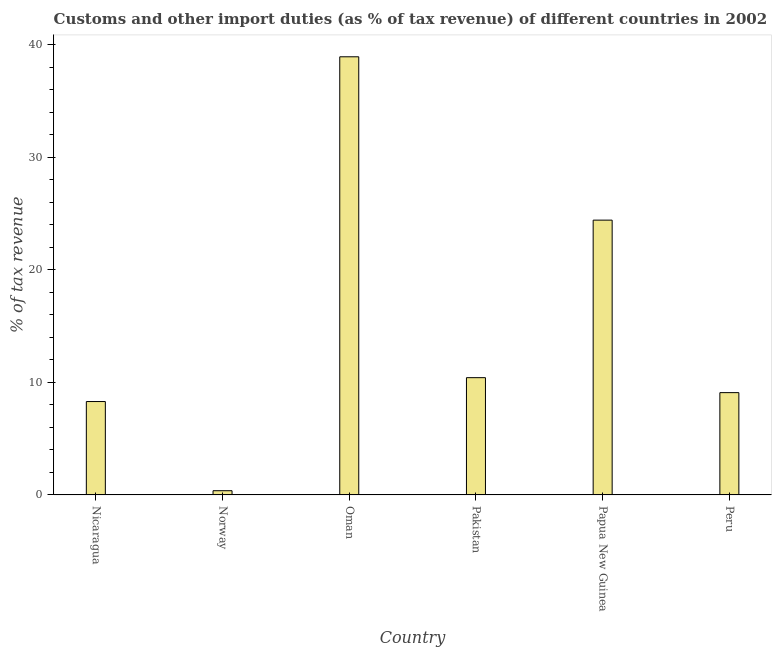Does the graph contain grids?
Provide a succinct answer. No. What is the title of the graph?
Ensure brevity in your answer.  Customs and other import duties (as % of tax revenue) of different countries in 2002. What is the label or title of the X-axis?
Your answer should be compact. Country. What is the label or title of the Y-axis?
Offer a very short reply. % of tax revenue. What is the customs and other import duties in Norway?
Your response must be concise. 0.38. Across all countries, what is the maximum customs and other import duties?
Offer a very short reply. 38.91. Across all countries, what is the minimum customs and other import duties?
Provide a short and direct response. 0.38. In which country was the customs and other import duties maximum?
Your answer should be very brief. Oman. What is the sum of the customs and other import duties?
Offer a very short reply. 91.49. What is the difference between the customs and other import duties in Nicaragua and Peru?
Your answer should be compact. -0.79. What is the average customs and other import duties per country?
Offer a very short reply. 15.25. What is the median customs and other import duties?
Your answer should be compact. 9.75. What is the ratio of the customs and other import duties in Nicaragua to that in Pakistan?
Make the answer very short. 0.8. Is the customs and other import duties in Nicaragua less than that in Papua New Guinea?
Your answer should be very brief. Yes. What is the difference between the highest and the second highest customs and other import duties?
Offer a terse response. 14.51. Is the sum of the customs and other import duties in Nicaragua and Oman greater than the maximum customs and other import duties across all countries?
Your response must be concise. Yes. What is the difference between the highest and the lowest customs and other import duties?
Give a very brief answer. 38.54. In how many countries, is the customs and other import duties greater than the average customs and other import duties taken over all countries?
Make the answer very short. 2. How many bars are there?
Ensure brevity in your answer.  6. How many countries are there in the graph?
Provide a succinct answer. 6. What is the % of tax revenue of Nicaragua?
Ensure brevity in your answer.  8.29. What is the % of tax revenue of Norway?
Offer a very short reply. 0.38. What is the % of tax revenue of Oman?
Provide a short and direct response. 38.91. What is the % of tax revenue in Pakistan?
Provide a succinct answer. 10.41. What is the % of tax revenue in Papua New Guinea?
Provide a succinct answer. 24.41. What is the % of tax revenue in Peru?
Offer a very short reply. 9.09. What is the difference between the % of tax revenue in Nicaragua and Norway?
Make the answer very short. 7.92. What is the difference between the % of tax revenue in Nicaragua and Oman?
Your answer should be very brief. -30.62. What is the difference between the % of tax revenue in Nicaragua and Pakistan?
Provide a succinct answer. -2.12. What is the difference between the % of tax revenue in Nicaragua and Papua New Guinea?
Keep it short and to the point. -16.11. What is the difference between the % of tax revenue in Nicaragua and Peru?
Give a very brief answer. -0.79. What is the difference between the % of tax revenue in Norway and Oman?
Your response must be concise. -38.54. What is the difference between the % of tax revenue in Norway and Pakistan?
Make the answer very short. -10.04. What is the difference between the % of tax revenue in Norway and Papua New Guinea?
Ensure brevity in your answer.  -24.03. What is the difference between the % of tax revenue in Norway and Peru?
Make the answer very short. -8.71. What is the difference between the % of tax revenue in Oman and Pakistan?
Provide a succinct answer. 28.5. What is the difference between the % of tax revenue in Oman and Papua New Guinea?
Provide a succinct answer. 14.51. What is the difference between the % of tax revenue in Oman and Peru?
Keep it short and to the point. 29.83. What is the difference between the % of tax revenue in Pakistan and Papua New Guinea?
Ensure brevity in your answer.  -13.99. What is the difference between the % of tax revenue in Pakistan and Peru?
Your answer should be very brief. 1.33. What is the difference between the % of tax revenue in Papua New Guinea and Peru?
Your answer should be very brief. 15.32. What is the ratio of the % of tax revenue in Nicaragua to that in Norway?
Offer a very short reply. 22.09. What is the ratio of the % of tax revenue in Nicaragua to that in Oman?
Make the answer very short. 0.21. What is the ratio of the % of tax revenue in Nicaragua to that in Pakistan?
Provide a short and direct response. 0.8. What is the ratio of the % of tax revenue in Nicaragua to that in Papua New Guinea?
Your answer should be compact. 0.34. What is the ratio of the % of tax revenue in Nicaragua to that in Peru?
Offer a terse response. 0.91. What is the ratio of the % of tax revenue in Norway to that in Pakistan?
Provide a succinct answer. 0.04. What is the ratio of the % of tax revenue in Norway to that in Papua New Guinea?
Provide a succinct answer. 0.01. What is the ratio of the % of tax revenue in Norway to that in Peru?
Give a very brief answer. 0.04. What is the ratio of the % of tax revenue in Oman to that in Pakistan?
Provide a short and direct response. 3.74. What is the ratio of the % of tax revenue in Oman to that in Papua New Guinea?
Give a very brief answer. 1.59. What is the ratio of the % of tax revenue in Oman to that in Peru?
Offer a terse response. 4.28. What is the ratio of the % of tax revenue in Pakistan to that in Papua New Guinea?
Give a very brief answer. 0.43. What is the ratio of the % of tax revenue in Pakistan to that in Peru?
Make the answer very short. 1.15. What is the ratio of the % of tax revenue in Papua New Guinea to that in Peru?
Your response must be concise. 2.69. 